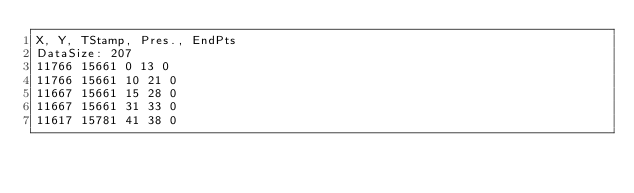<code> <loc_0><loc_0><loc_500><loc_500><_SML_>X, Y, TStamp, Pres., EndPts
DataSize: 207
11766 15661 0 13 0
11766 15661 10 21 0
11667 15661 15 28 0
11667 15661 31 33 0
11617 15781 41 38 0</code> 